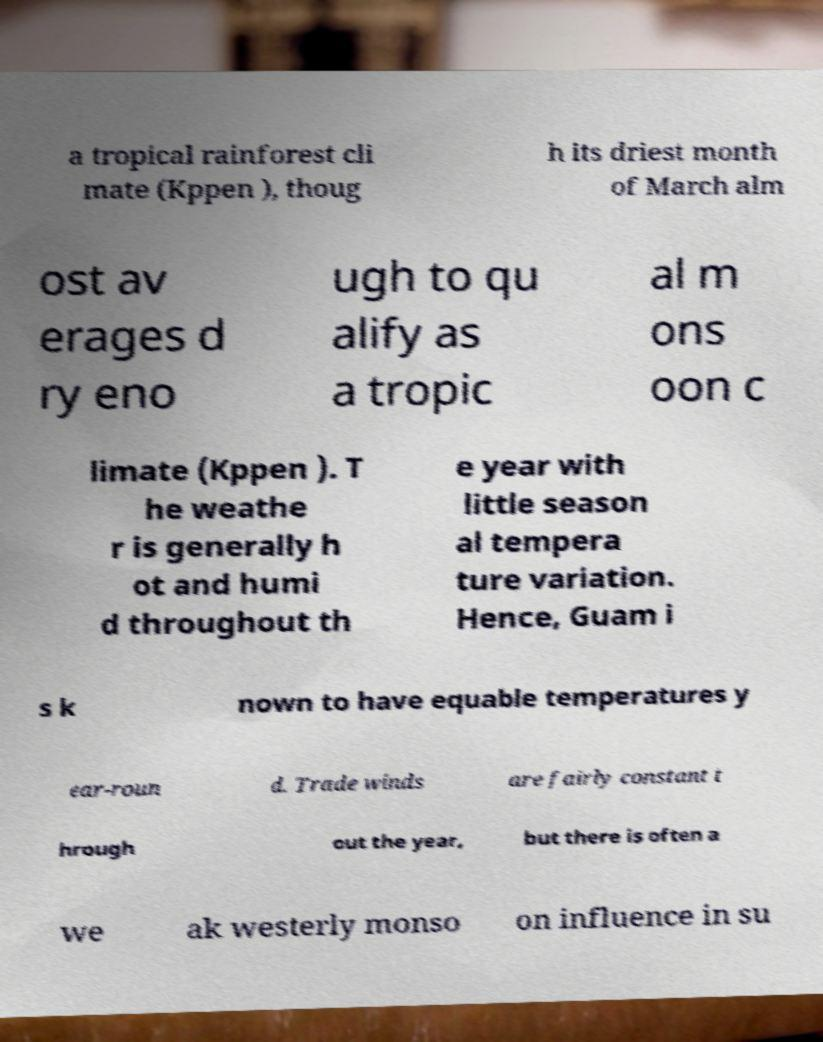Please read and relay the text visible in this image. What does it say? a tropical rainforest cli mate (Kppen ), thoug h its driest month of March alm ost av erages d ry eno ugh to qu alify as a tropic al m ons oon c limate (Kppen ). T he weathe r is generally h ot and humi d throughout th e year with little season al tempera ture variation. Hence, Guam i s k nown to have equable temperatures y ear-roun d. Trade winds are fairly constant t hrough out the year, but there is often a we ak westerly monso on influence in su 